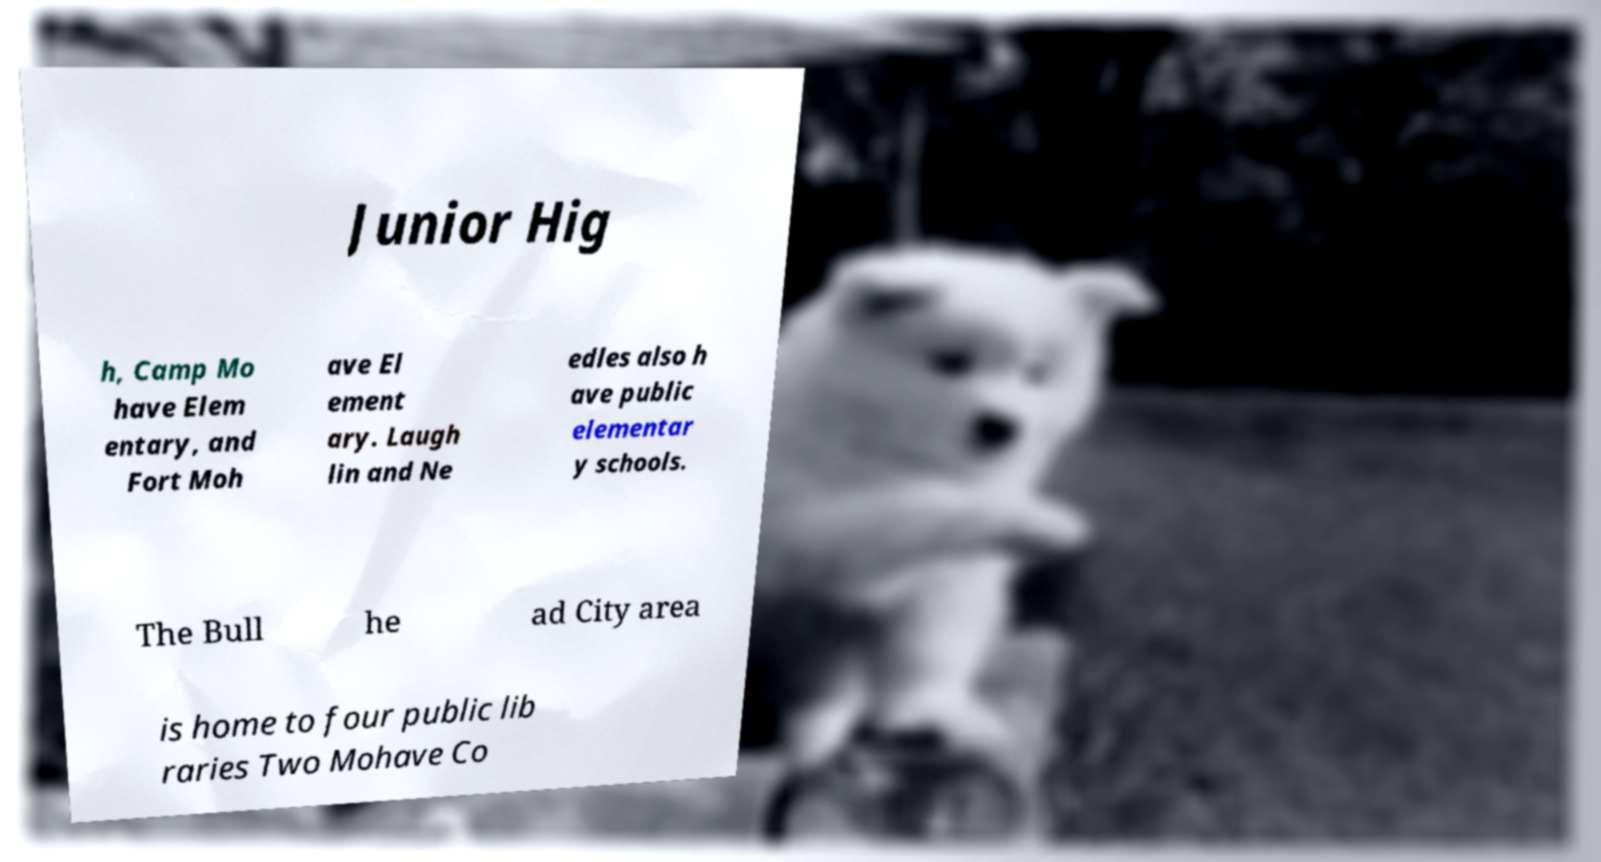Please read and relay the text visible in this image. What does it say? Junior Hig h, Camp Mo have Elem entary, and Fort Moh ave El ement ary. Laugh lin and Ne edles also h ave public elementar y schools. The Bull he ad City area is home to four public lib raries Two Mohave Co 